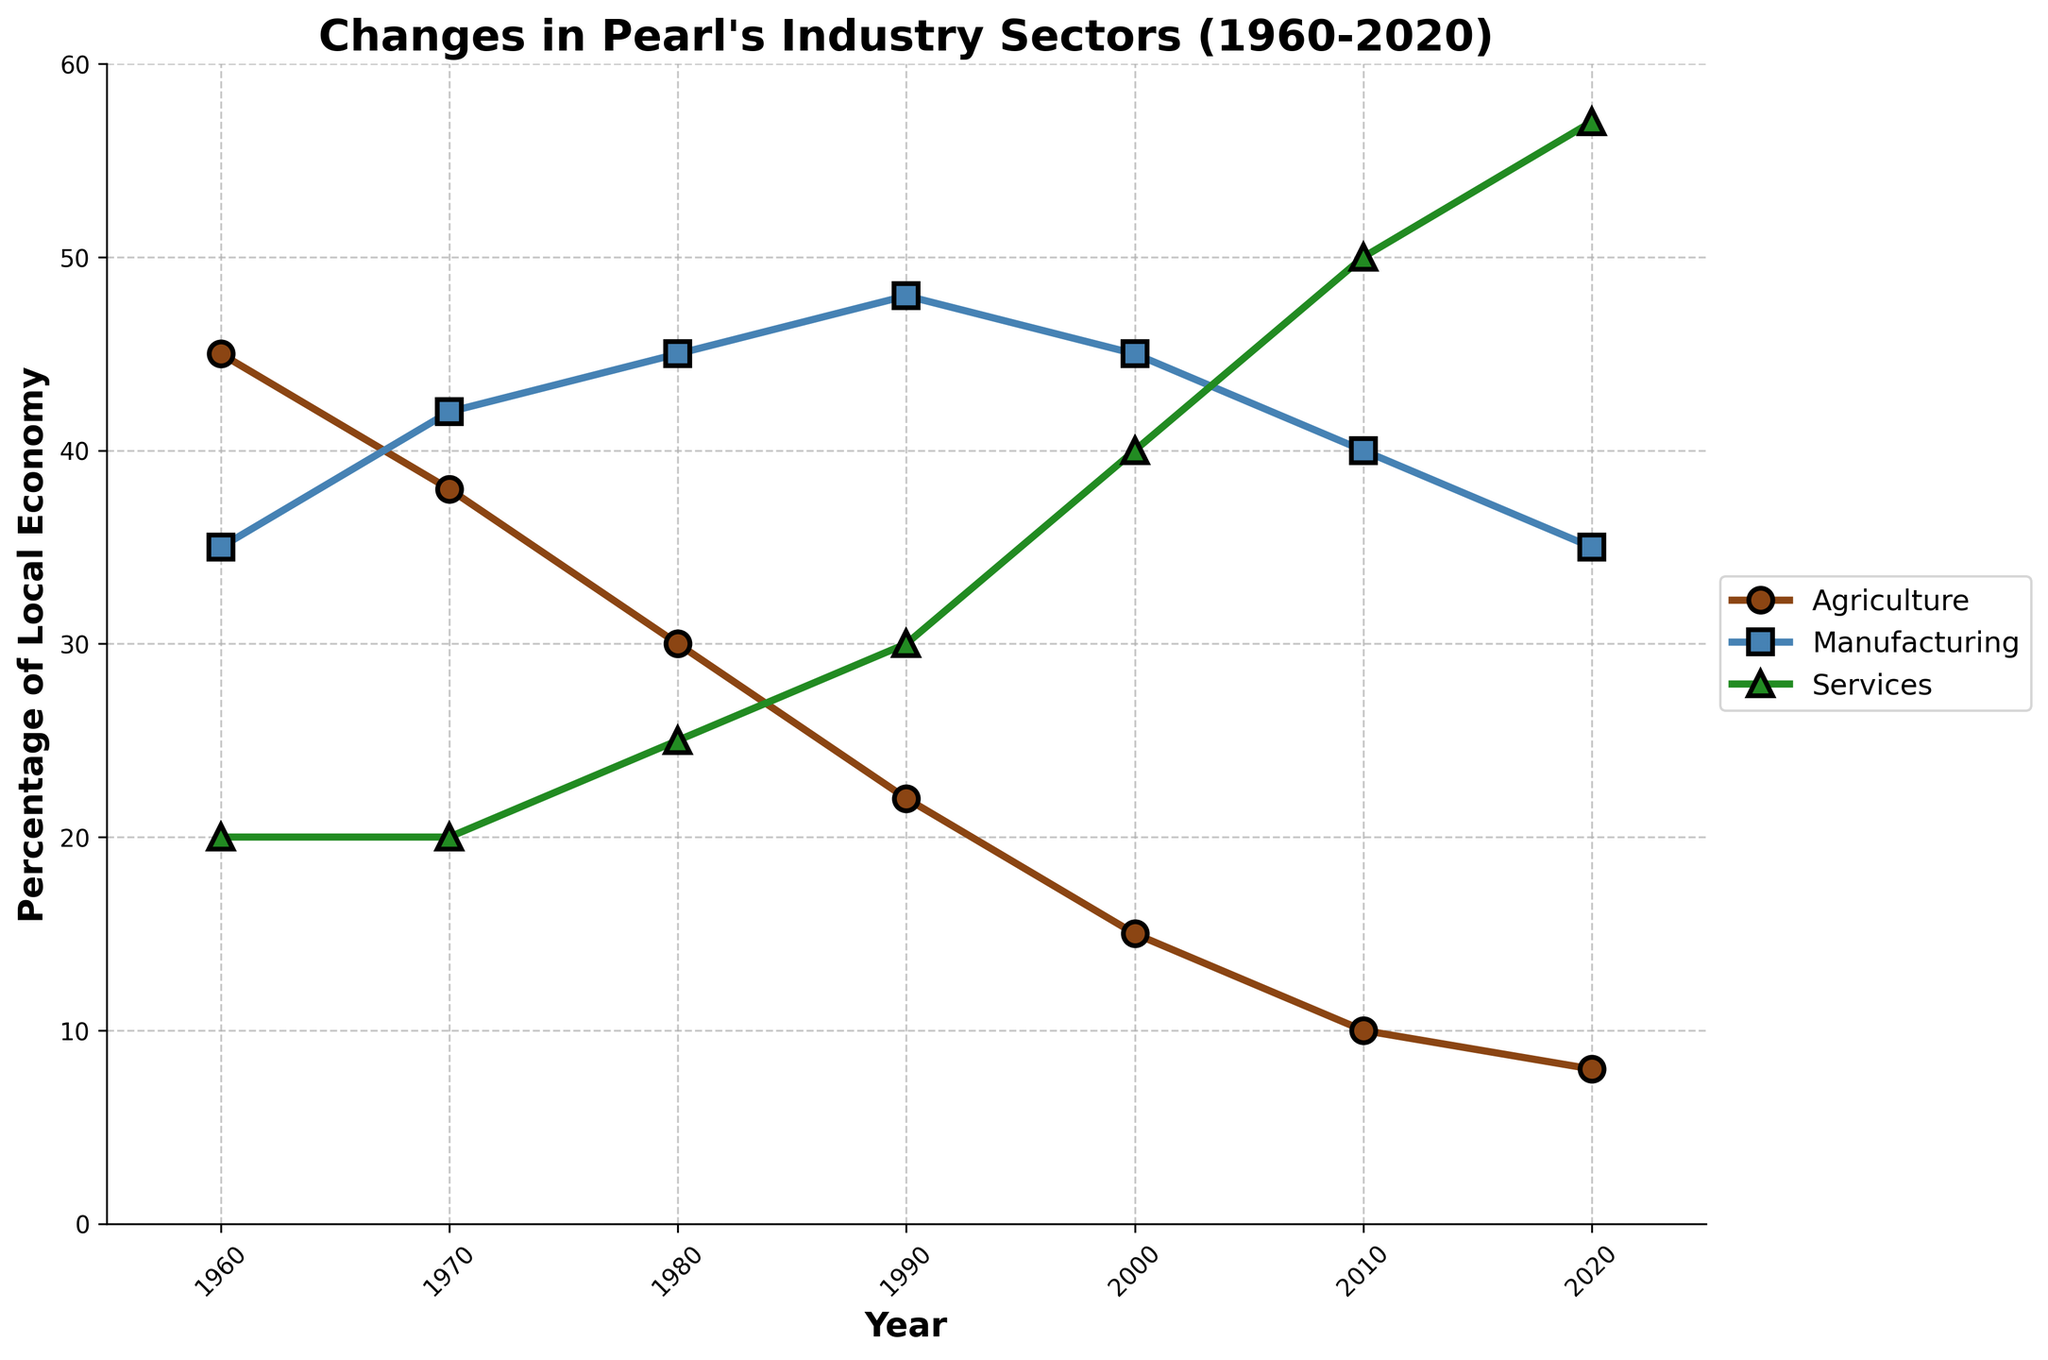What was the percentage of agriculture in Pearl's local economy in 1960? Look at the data point corresponding to 1960 on the line chart for agriculture.
Answer: 45% Which sector had the highest percentage of the local economy in 2020? By comparing the three sectors' data points for 2020, the services sector has the highest percentage.
Answer: Services What are the total percentages of agriculture and manufacturing in the local economy for the year 2000? Add the percentage values for agriculture and manufacturing from the year 2000. 15% (agriculture) + 45% (manufacturing) = 60%
Answer: 60% How did the percentage of services change between 1960 and 2020? Subtract the percentage in 1960 from the percentage in 2020 for services. 57% (2020) - 20% (1960) = 37%
Answer: 37% In which decade did agriculture experience the steepest decline? Compare the decline of agriculture for each decade by calculating the differences: 
1960-1970: 45 - 38 = 7, 
1970-1980: 38 - 30 = 8,
1980-1990: 30 - 22 = 8,
1990-2000: 22 - 15 = 7,
2000-2010: 15 - 10 = 5,
2010-2020: 10 - 8 = 2. The largest declines are both 8% in the decades 1970-1980 and 1980-1990.
Answer: 1970-1980 and 1980-1990 Compare the percentage of manufacturing in 1980 to 1970. The percentage of manufacturing in 1980 is 45% compared to 42% in 1970. The difference is 45% - 42% = 3%.
Answer: 3% What was the average percentage of the local economy made up by services from 1960 to 2020? Find the average by adding up the services percentages for all the years and dividing by the number of years: (20+20+25+30+40+50+57) / 7 = 242 / 7 ≈ 34.57%.
Answer: 34.57% Between which two consecutive decades did the manufacturing sector's percentage remain the most consistent? Compare the percentage change for each decade increment:
1960-1970: 35 - 42 = -7,
1970-1980: 42 - 45 = -3,
1980-1990: 45 - 48 = -3,
1990-2000: 48 - 45 = 3,
2000-2010: 45 - 40 = 5,
2010-2020: 40 - 35 = 5. The most consistent (smallest change) is between 1970-1980 and 1980-1990 with a 3% change each time.
Answer: 1970-1980, 1980-1990 How did the proportion of agriculture and services compare in 2010? Look at the data points for 2010. Agriculture is at 10%, and services are at 50%. Services are 40% higher than agriculture.
Answer: 40% Identify the year when manufacturing had its peak percentage. Compare the manufacturing percentage across all years. The highest percentage is 48% in 1990.
Answer: 1990 